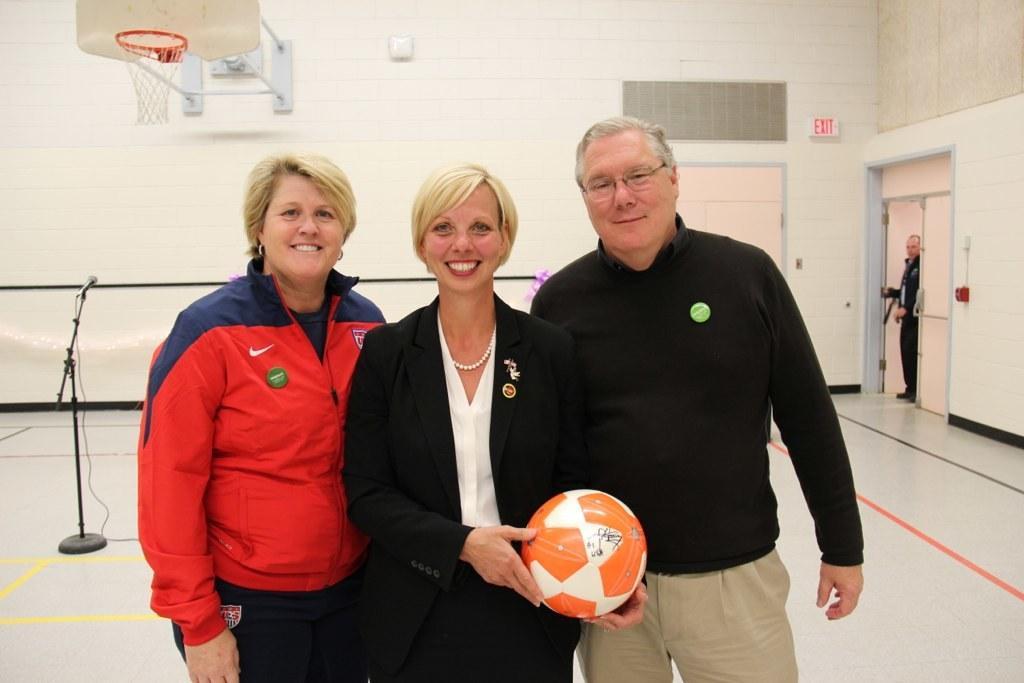Describe this image in one or two sentences. There are three members standing in this picture. Two of them were women. One of them was man. The middle one is holding a ball in her hands. In the background there is a mic and a stand. We can observe a basketball net and a wall here. 